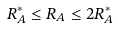Convert formula to latex. <formula><loc_0><loc_0><loc_500><loc_500>R ^ { * } _ { A } \leq R _ { A } \leq 2 R ^ { * } _ { A }</formula> 